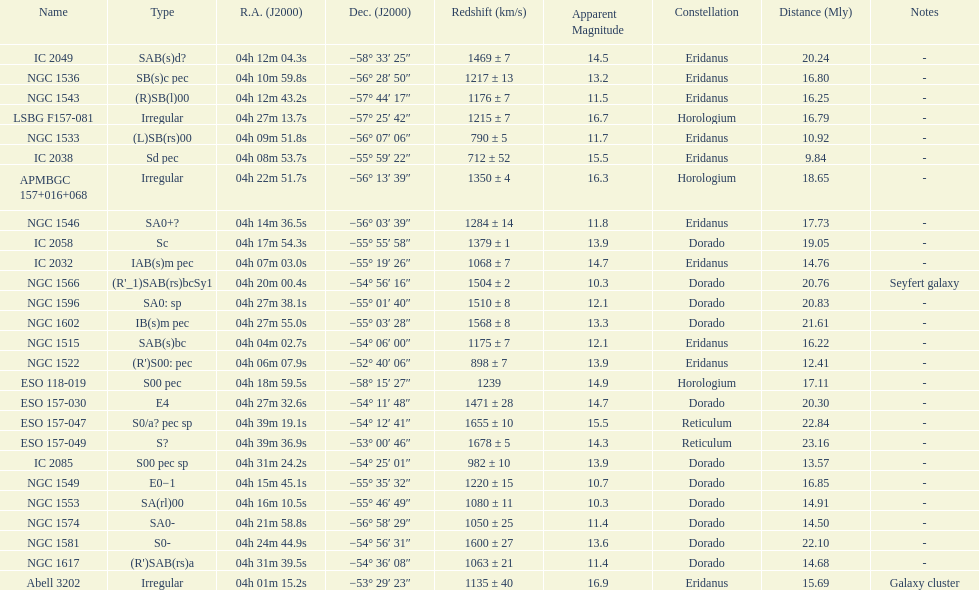What number of "irregular" types are there? 3. 